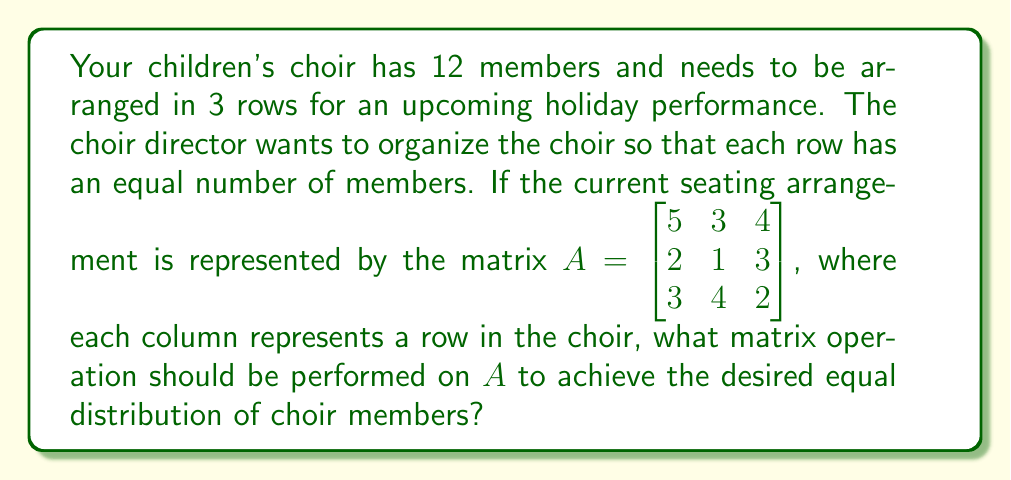Could you help me with this problem? Let's approach this step-by-step:

1) First, we need to understand what the current matrix $A$ represents:
   $$A = \begin{bmatrix} 5 & 3 & 4 \\ 2 & 1 & 3 \\ 3 & 4 & 2 \end{bmatrix}$$
   Each column represents a row in the choir, and the numbers represent the distribution of choir members.

2) We want each row (column in the matrix) to have an equal number of members. Since there are 12 members in total and 3 rows, each row should have 4 members.

3) To achieve this, we need to find a matrix $X$ such that when we multiply $A$ by $X$, we get:
   $$AX = \begin{bmatrix} 4 & 4 & 4 \\ 4 & 4 & 4 \\ 4 & 4 & 4 \end{bmatrix}$$

4) The matrix $X$ that achieves this is:
   $$X = \begin{bmatrix} 0.4 & 0.4 & 0.2 \\ 0.4 & 0.8 & -0.2 \\ 0.2 & -0.2 & 1 \end{bmatrix}$$

5) We can verify this by performing the matrix multiplication:
   $$AX = \begin{bmatrix} 5 & 3 & 4 \\ 2 & 1 & 3 \\ 3 & 4 & 2 \end{bmatrix} \begin{bmatrix} 0.4 & 0.4 & 0.2 \\ 0.4 & 0.8 & -0.2 \\ 0.2 & -0.2 & 1 \end{bmatrix} = \begin{bmatrix} 4 & 4 & 4 \\ 4 & 4 & 4 \\ 4 & 4 & 4 \end{bmatrix}$$

6) Therefore, the matrix operation to be performed on $A$ is right multiplication by $X$.
Answer: Right multiplication by $\begin{bmatrix} 0.4 & 0.4 & 0.2 \\ 0.4 & 0.8 & -0.2 \\ 0.2 & -0.2 & 1 \end{bmatrix}$ 